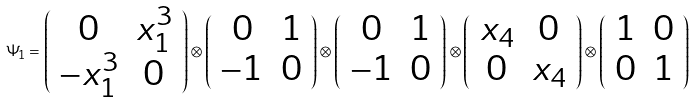Convert formula to latex. <formula><loc_0><loc_0><loc_500><loc_500>\Psi _ { 1 } = \left ( \begin{array} { c c } 0 & x _ { 1 } ^ { 3 } \\ - x _ { 1 } ^ { 3 } & 0 \end{array} \right ) \otimes \left ( \begin{array} { c c } 0 & 1 \\ - 1 & 0 \end{array} \right ) \otimes \left ( \begin{array} { c c } 0 & 1 \\ - 1 & 0 \end{array} \right ) \otimes \left ( \begin{array} { c c } x _ { 4 } & 0 \\ 0 & x _ { 4 } \end{array} \right ) \otimes \left ( \begin{array} { c c } 1 & 0 \\ 0 & 1 \end{array} \right )</formula> 